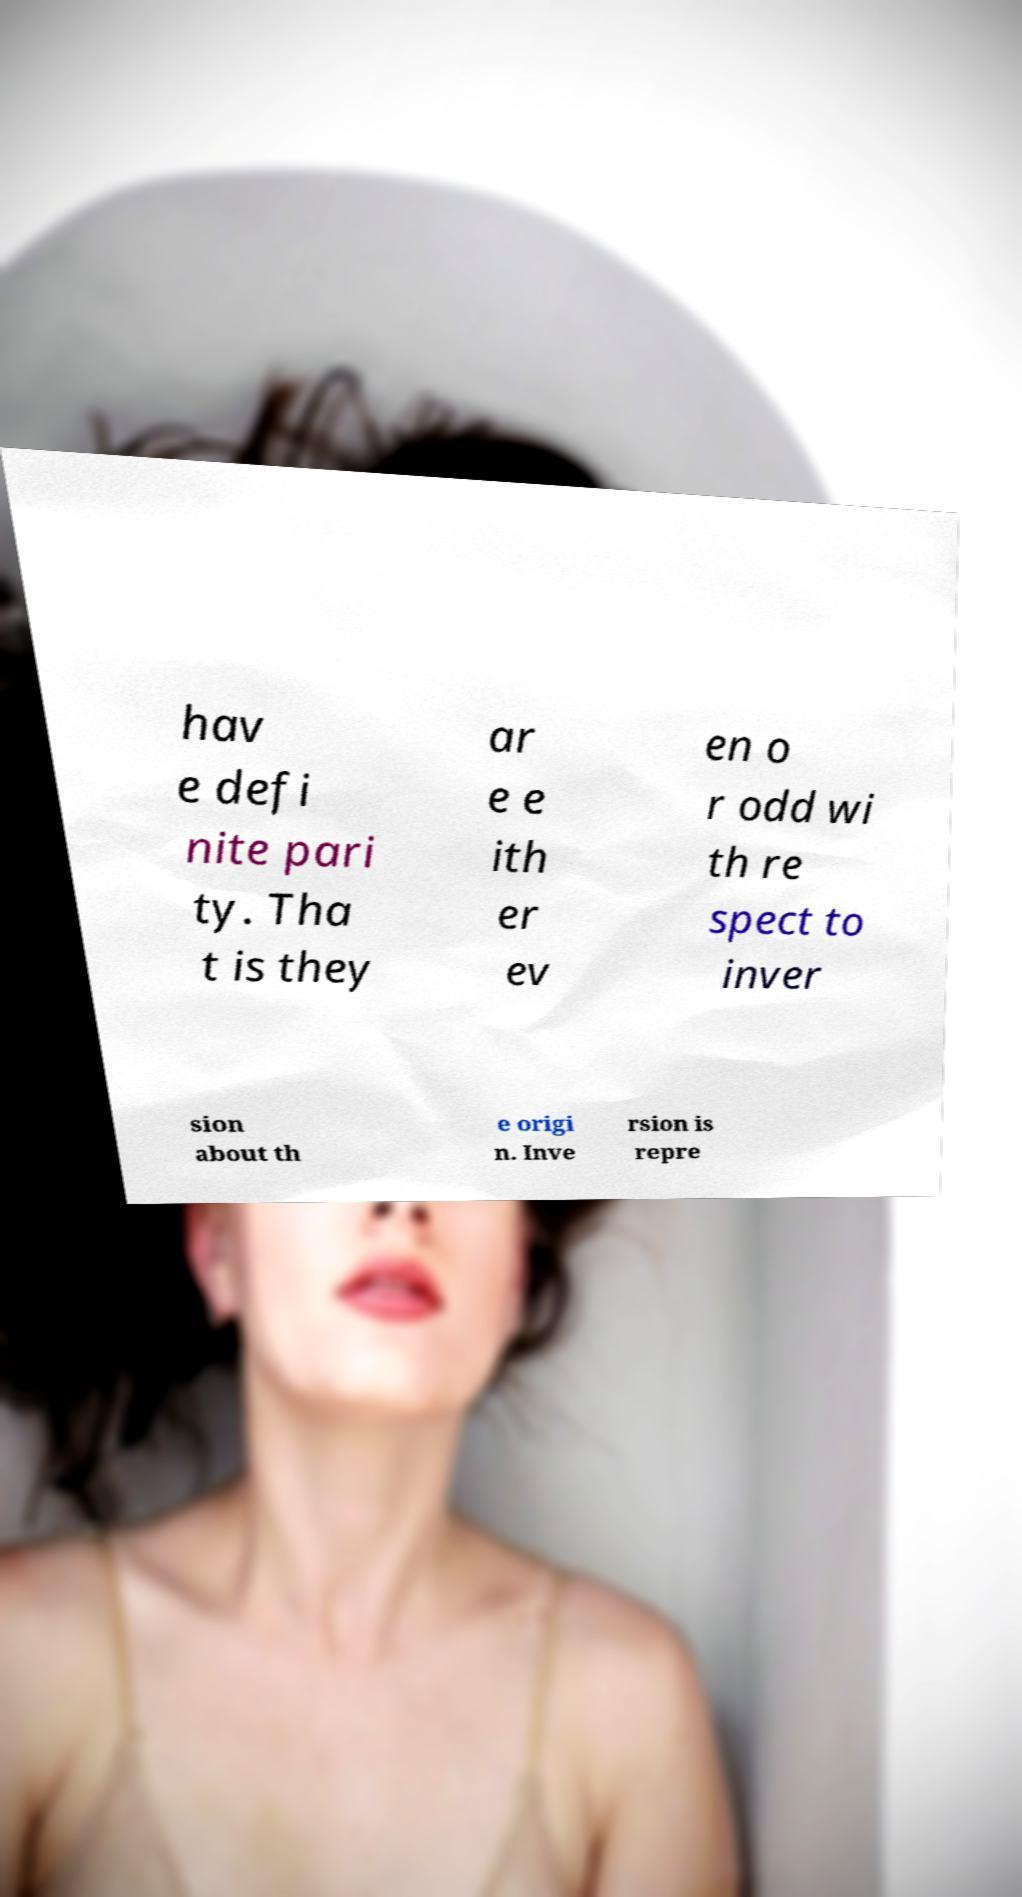Can you read and provide the text displayed in the image?This photo seems to have some interesting text. Can you extract and type it out for me? hav e defi nite pari ty. Tha t is they ar e e ith er ev en o r odd wi th re spect to inver sion about th e origi n. Inve rsion is repre 